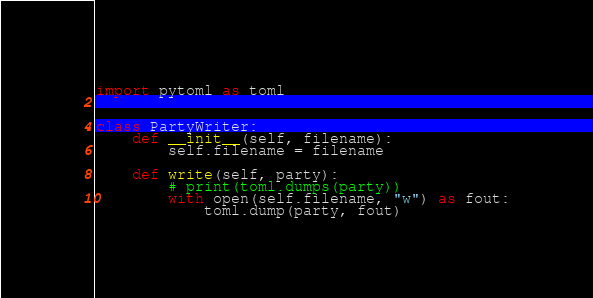<code> <loc_0><loc_0><loc_500><loc_500><_Python_>import pytoml as toml


class PartyWriter:
    def __init__(self, filename):
        self.filename = filename

    def write(self, party):
        # print(toml.dumps(party))
        with open(self.filename, "w") as fout:
            toml.dump(party, fout)
</code> 